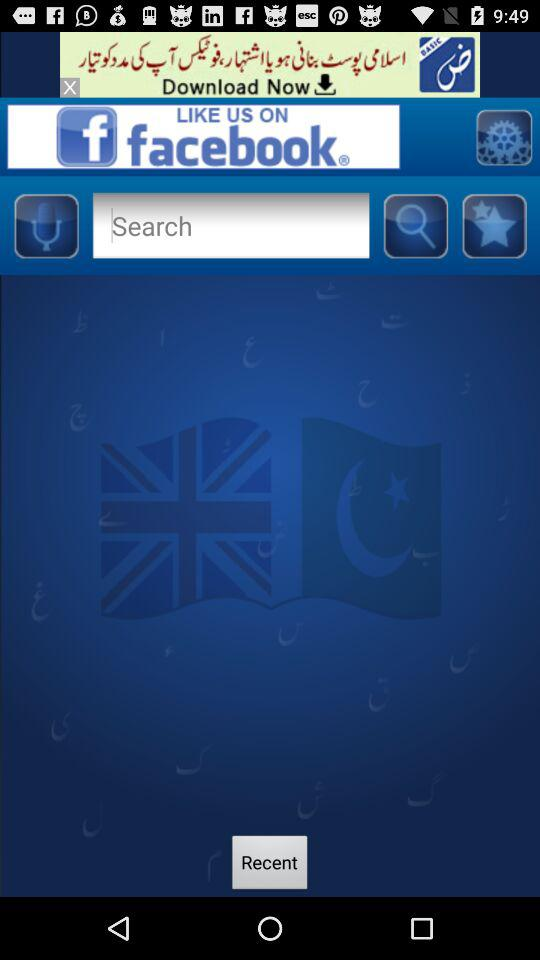How many Facebook likes are there?
When the provided information is insufficient, respond with <no answer>. <no answer> 